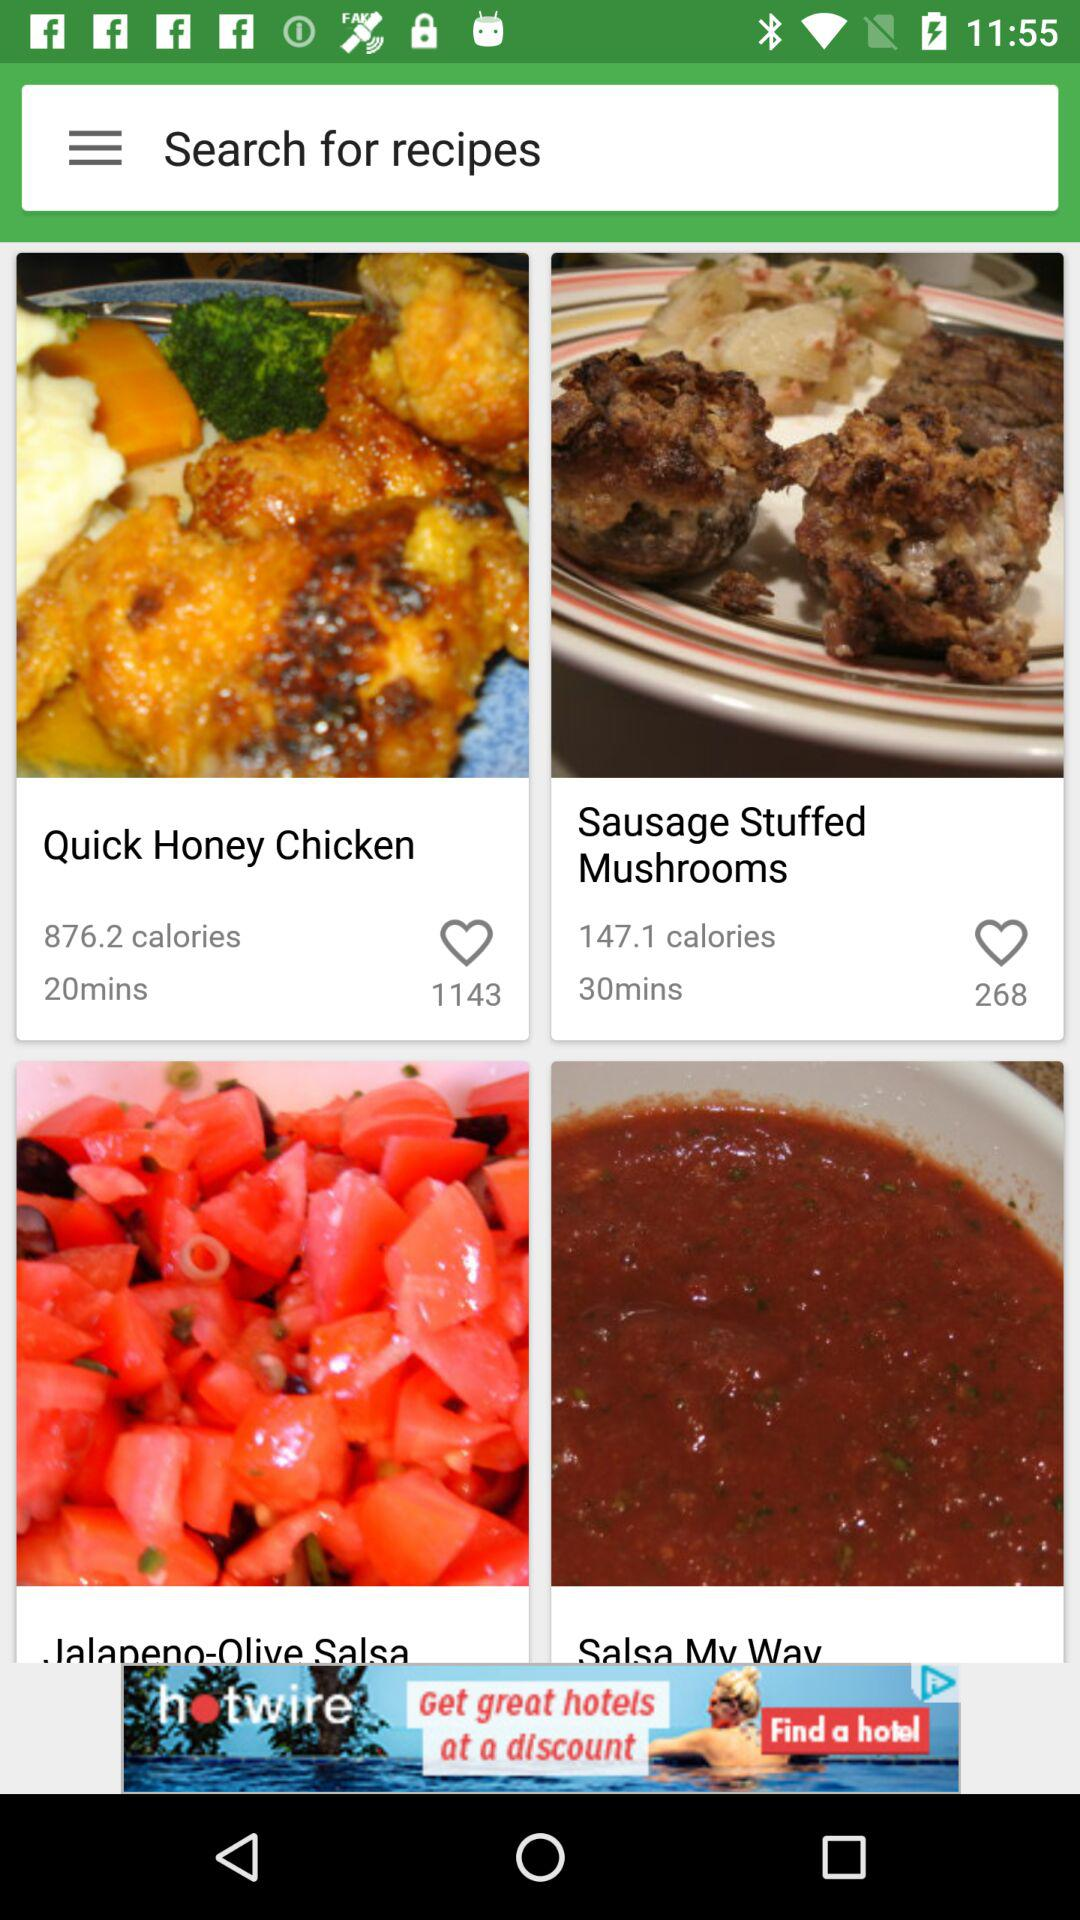How many likes did the "Sausage Stuffed Mushrooms" get? The "Sausage Stuffed Mushrooms" got 268 likes. 